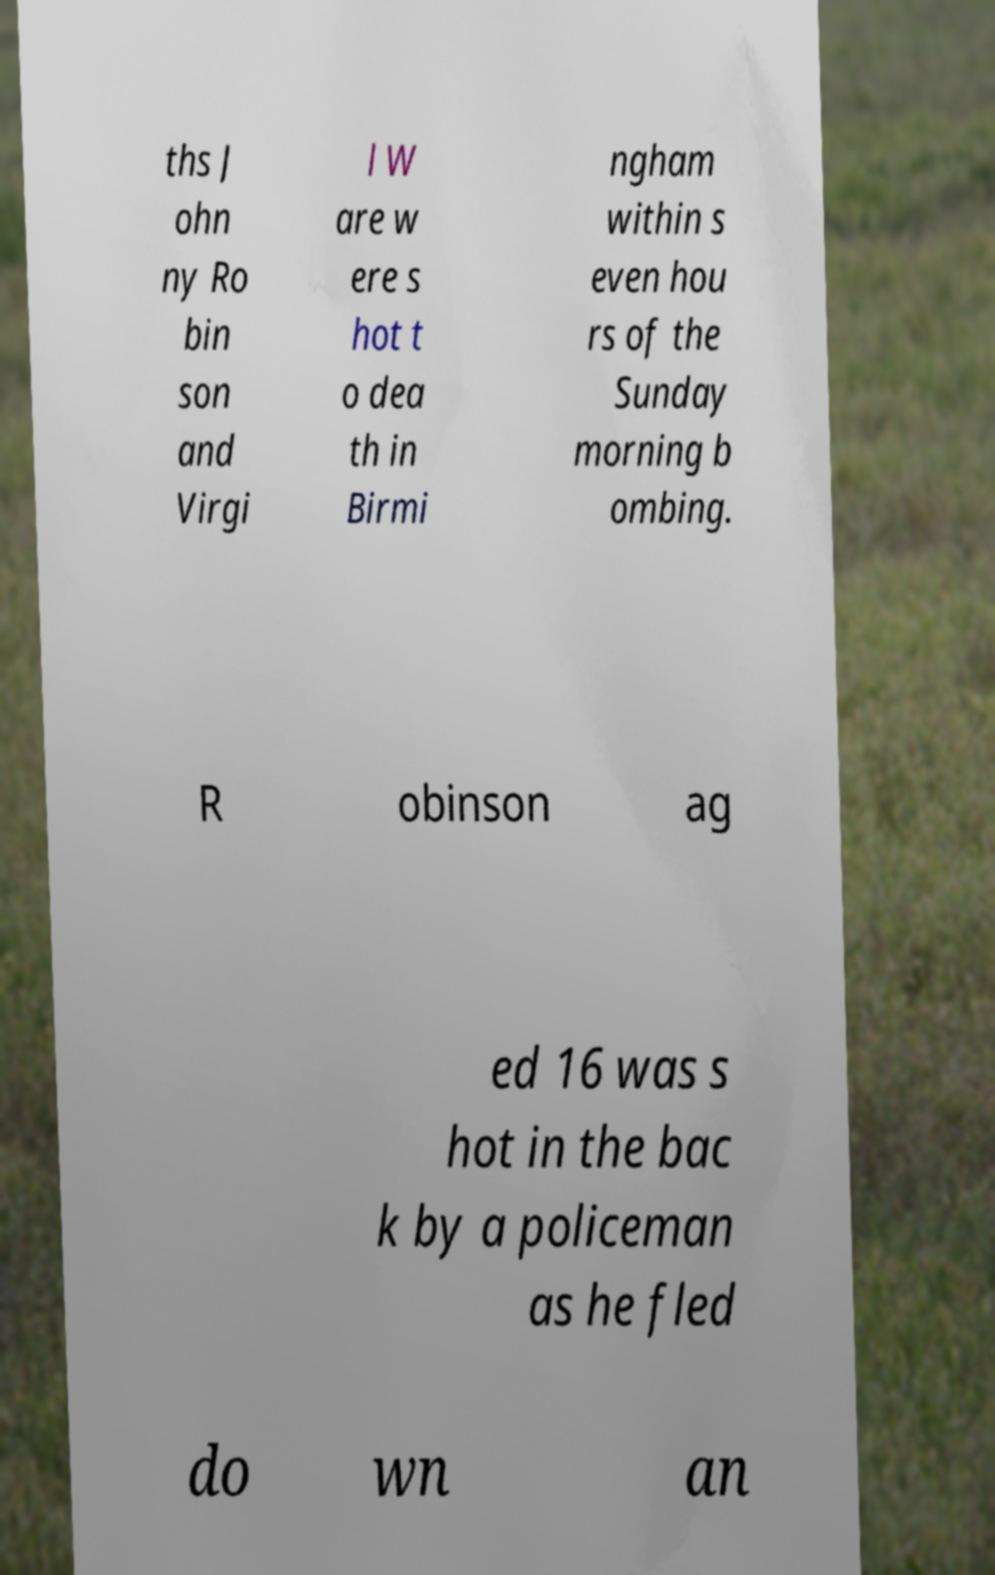Please identify and transcribe the text found in this image. ths J ohn ny Ro bin son and Virgi l W are w ere s hot t o dea th in Birmi ngham within s even hou rs of the Sunday morning b ombing. R obinson ag ed 16 was s hot in the bac k by a policeman as he fled do wn an 